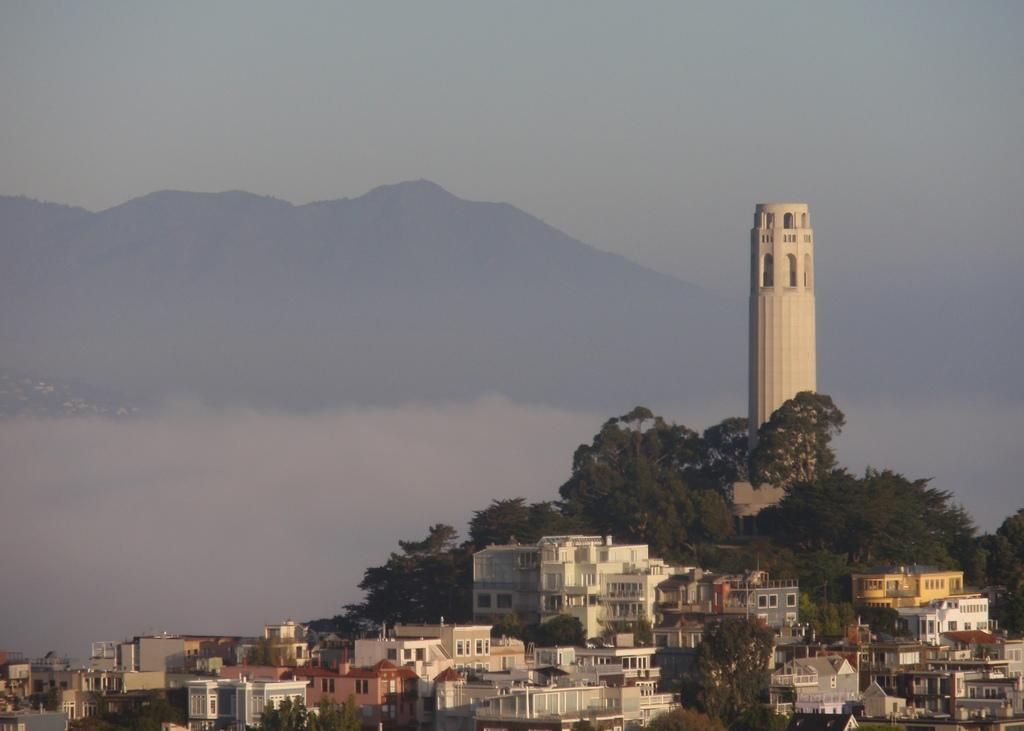What type of structures can be seen in the image? There are buildings in the image. What other natural elements are present in the image? There are trees in the image. What specific feature stands out among the buildings? There is a tower in the image. What can be seen in the distance behind the buildings and trees? In the background of the image, there are hills. How many feet are visible in the image? There are no feet present in the image. What type of meeting is taking place in the image? There is no meeting depicted in the image. 